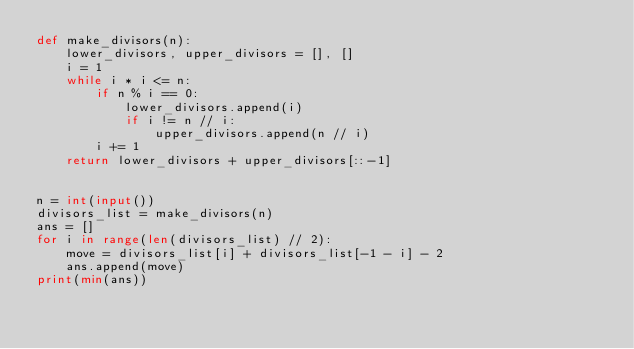<code> <loc_0><loc_0><loc_500><loc_500><_Python_>def make_divisors(n):
    lower_divisors, upper_divisors = [], []
    i = 1
    while i * i <= n:
        if n % i == 0:
            lower_divisors.append(i)
            if i != n // i:
                upper_divisors.append(n // i)
        i += 1
    return lower_divisors + upper_divisors[::-1]


n = int(input())
divisors_list = make_divisors(n)
ans = []
for i in range(len(divisors_list) // 2):
    move = divisors_list[i] + divisors_list[-1 - i] - 2
    ans.append(move)
print(min(ans))
</code> 